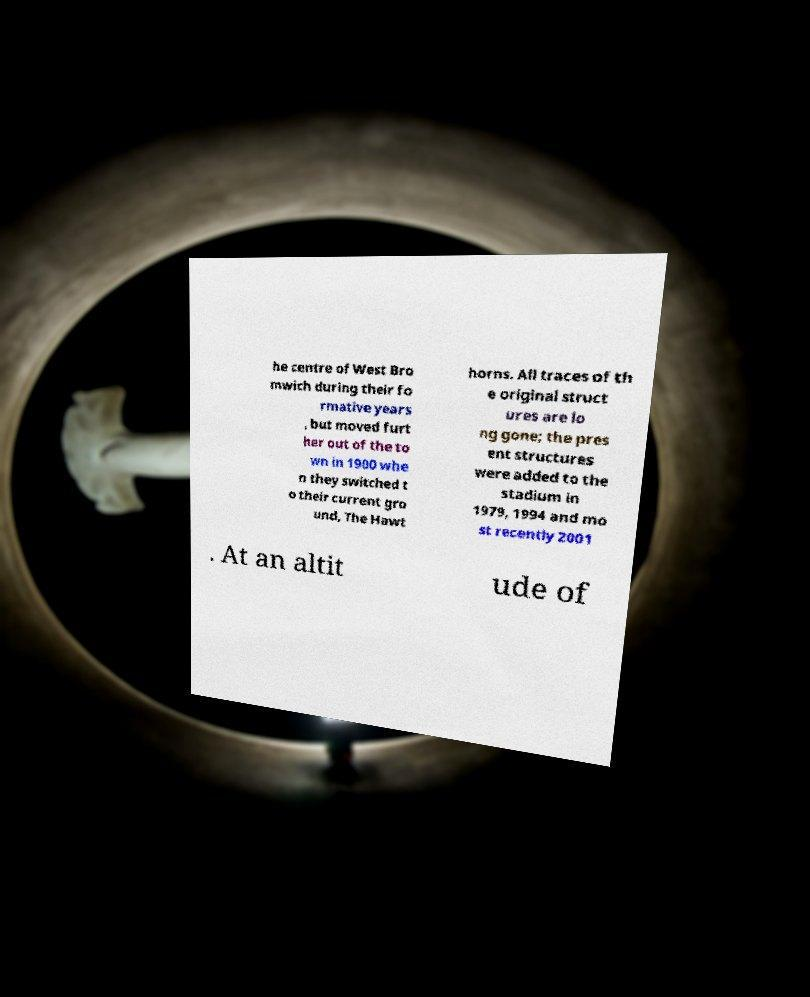Please read and relay the text visible in this image. What does it say? he centre of West Bro mwich during their fo rmative years , but moved furt her out of the to wn in 1900 whe n they switched t o their current gro und, The Hawt horns. All traces of th e original struct ures are lo ng gone; the pres ent structures were added to the stadium in 1979, 1994 and mo st recently 2001 . At an altit ude of 